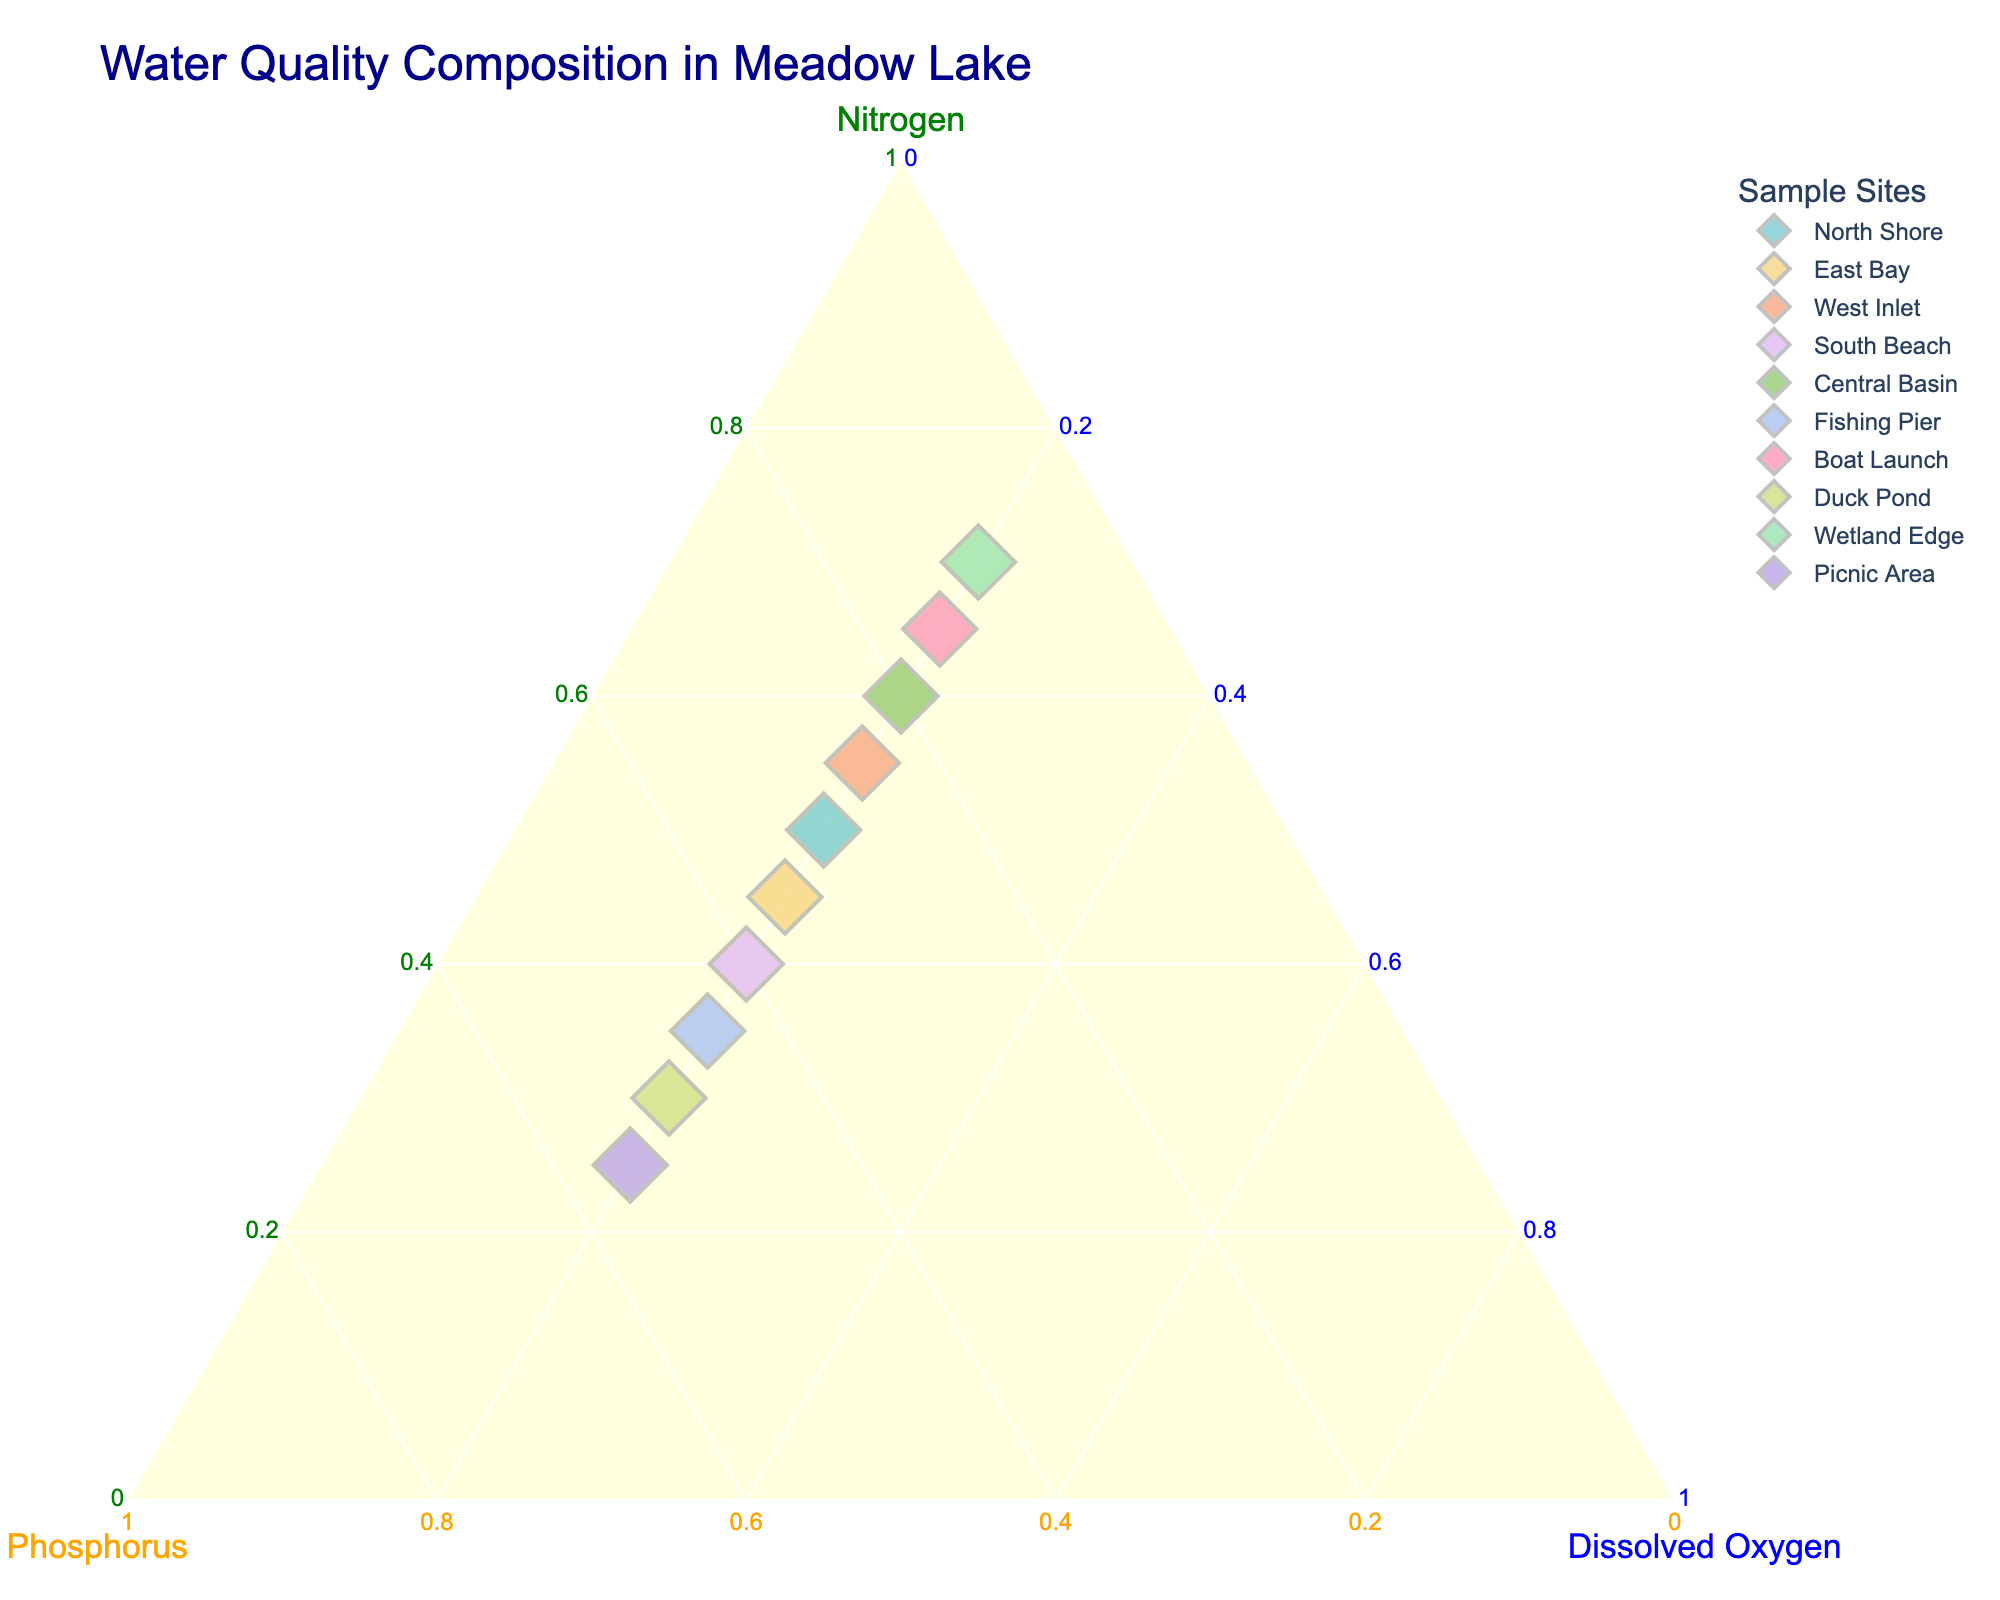What's the title of the ternary plot? The title of the plot is displayed at the top in a larger font. It provides a summary of what the plot represents.
Answer: Water Quality Composition in Meadow Lake How many sample sites are there represented in the scatter plot? Count the different colored markers, each representing a distinct sample site.
Answer: 10 Which sample site has the highest percentage of phosphorus? Identify the data point that is the furthest along the phosphorus axis (b-axis).
Answer: Picnic Area Which sample site has the lowest percentage of nitrogen? Identify the data point that is closest to the Phosphorus-Dissolved Oxygen side of the ternary plot.
Answer: Picnic Area What is the percentage composition of dissolved oxygen in all sample sites? Each data point should be situated on the 20% dissolved oxygen vector.
Answer: 20% Which sample site has an equal distribution of nitrogen and phosphorus levels? Look for the point where the values for nitrogen and phosphorus are the same; this is along the bisector line of the phosphorus-nitrogen axis.
Answer: South Beach Compare the nitrogen levels of the North Shore and Wetland Edge sample sites. Which one is higher? Look for both sample sites and compare their positions along the nitrogen axis.
Answer: Wetland Edge Which sample site is closest to the nitrogen (a-axis) corner of the ternary plot? Identify the point that is nearest to the nitrogen axis.
Answer: Wetland Edge What's the average percentage of nitrogen for the South Beach, Central Basin, and Fishing Pier sample sites? Add the percentages of nitrogen for these three sites and then divide by 3. (40 + 60 + 35) / 3 = 45
Answer: 45% Are there any sample sites with a phosphorus percentage higher than 50%? Look along the phosphorus axis for any points that are above the 50% mark.
Answer: Yes, Duck Pond and Picnic Area 